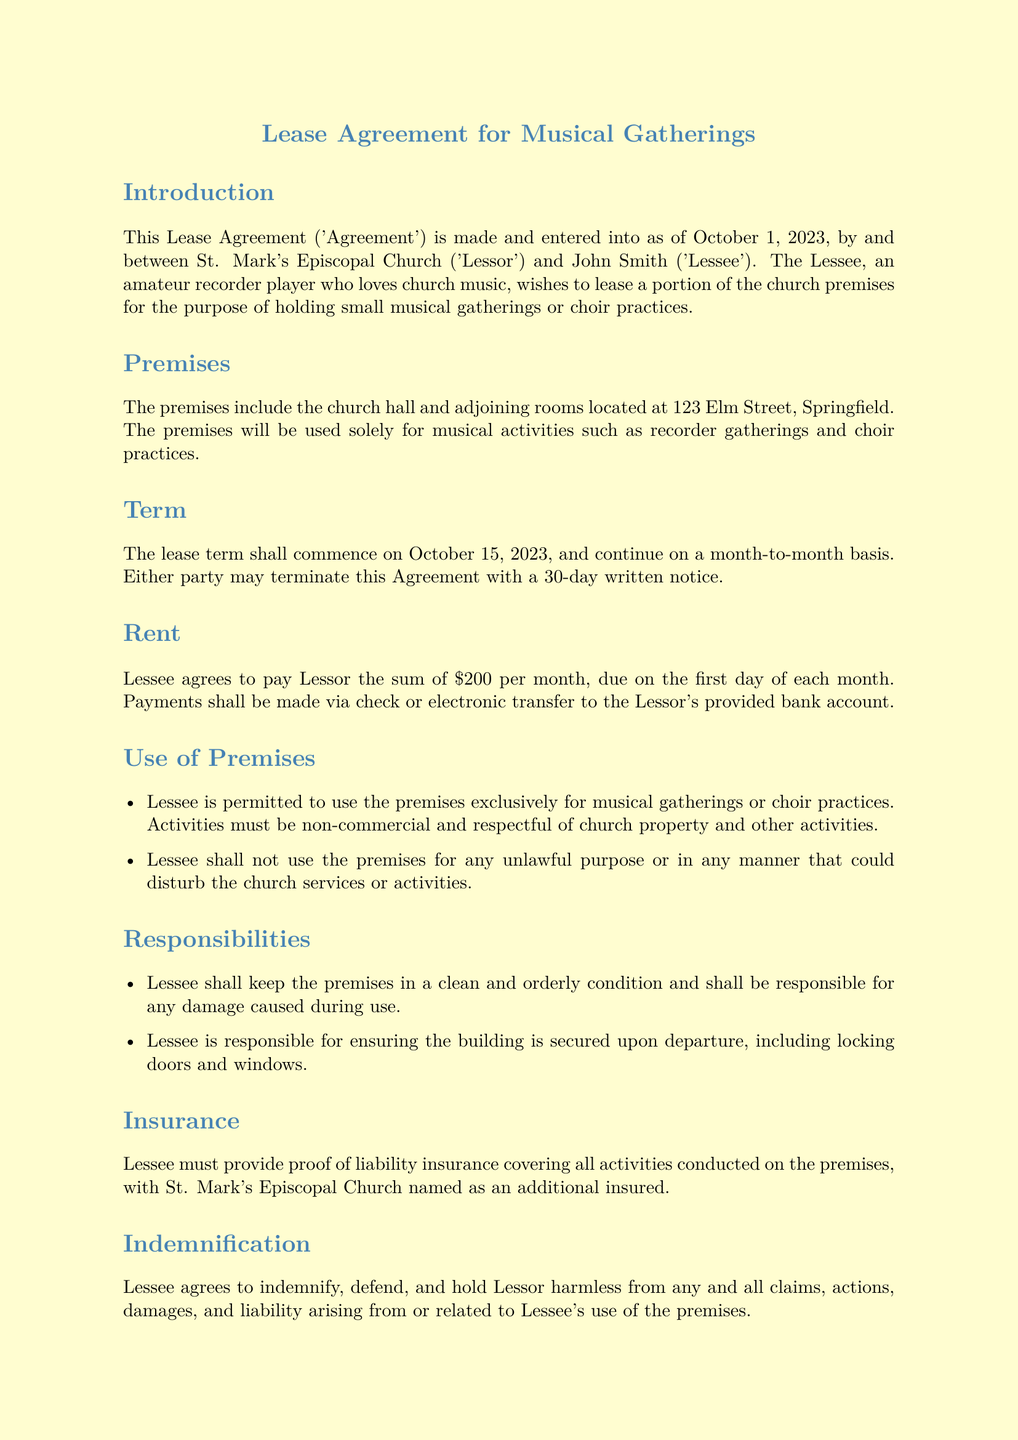what is the name of the Lessor? The Lessor is identified as St. Mark's Episcopal Church in the lease agreement.
Answer: St. Mark's Episcopal Church who is the Lessee? The Lessee is named John Smith as per the document.
Answer: John Smith what is the rent amount? The document states that the rent amount is set at \$200 per month.
Answer: \$200 when does the lease term commence? The lease term commencement date is specified as October 15, 2023.
Answer: October 15, 2023 how long is the notice period for termination? The notice period required for termination of the agreement is 30 days.
Answer: 30 days what is the primary purpose of using the premises? The premises are to be used solely for musical gatherings or choir practices according to the document.
Answer: musical gatherings or choir practices is the Lessee allowed to use personal musical equipment? Yes, the document allows the Lessee to bring and use personal musical instruments and equipment.
Answer: Yes what must the Lessee provide related to insurance? The Lessee must provide proof of liability insurance with St. Mark's Episcopal Church named as an additional insured.
Answer: proof of liability insurance are the musical activities allowed to disturb nearby residents? No, all musical activities must comply with local noise ordinances and must not disturb nearby residents.
Answer: No 